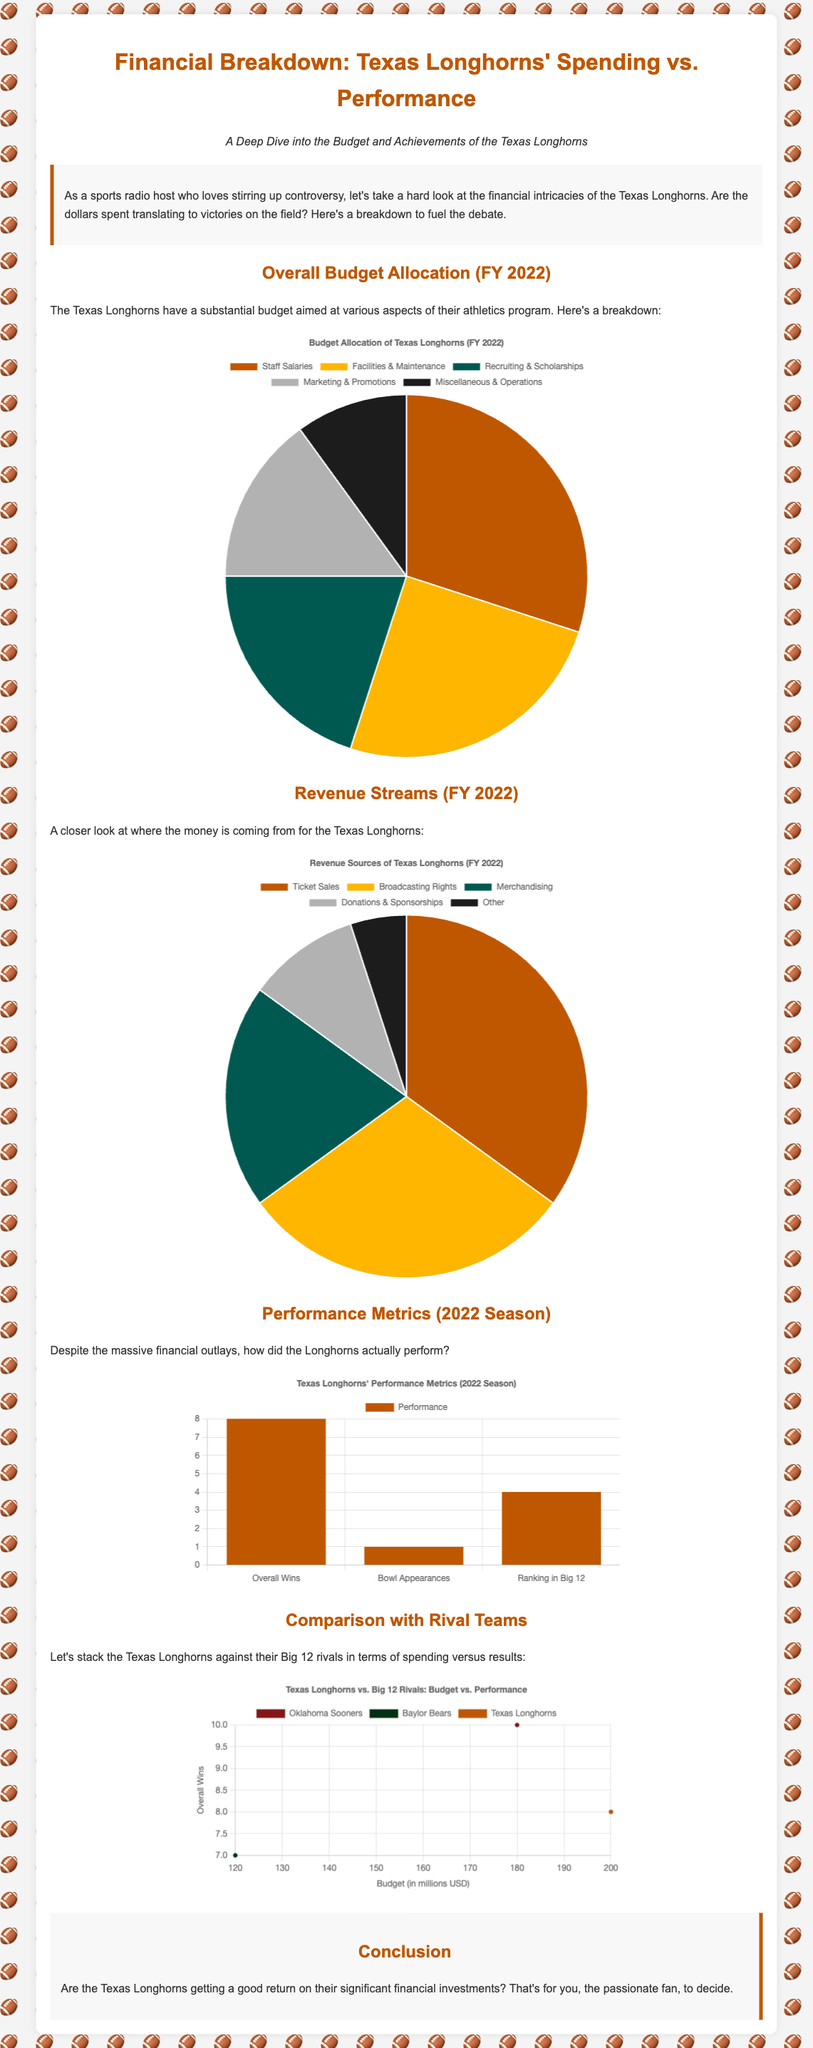What is the largest budget allocation category? According to the budget allocation pie chart, the largest category is "Staff Salaries" at 30%.
Answer: Staff Salaries How many overall wins did the Texas Longhorns have in the 2022 season? The performance metrics chart indicates that the Texas Longhorns had 8 overall wins in the 2022 season.
Answer: 8 What percentage of revenue comes from Ticket Sales? The revenue streams pie chart shows that 35% of the revenue comes from Ticket Sales.
Answer: 35% What is the total amount of budget allocated to the Texas Longhorns? While the total amount is not explicitly stated, the largest budget category is 30%, indicating significant investment.
Answer: Not specified Which rival has the highest budget according to the scatter plot? The scatter plot indicates that the Oklahoma Sooners have the highest budget at 180 million USD.
Answer: Oklahoma Sooners How many bowl appearances did the Texas Longhorns have in the 2022 season? The performance metrics chart lists 1 bowl appearance for the Texas Longhorns in the 2022 season.
Answer: 1 What is the ranking of the Texas Longhorns in the Big 12? The performance metrics chart shows that the Texas Longhorns ranked 4th in the Big 12.
Answer: 4 What is the primary source of revenue for the Texas Longhorns? According to the revenue streams chart, the primary source is Ticket Sales.
Answer: Ticket Sales Which category accounts for the least budget allocation? The budget allocation pie chart reveals that "Miscellaneous & Operations" accounts for the least allocation at 10%.
Answer: Miscellaneous & Operations 